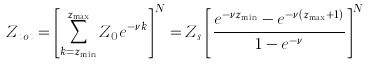<formula> <loc_0><loc_0><loc_500><loc_500>Z _ { t o t } = \left [ \sum _ { k = { z } _ { \min } } ^ { { z } _ { \max } } Z _ { 0 } e ^ { - \nu k } \right ] ^ { N } = Z _ { s } \left [ \frac { e ^ { - \nu { z } _ { \min } } - e ^ { - \nu ( { z } _ { \max } + 1 ) } } { 1 - e ^ { - \nu } } \right ] ^ { N }</formula> 